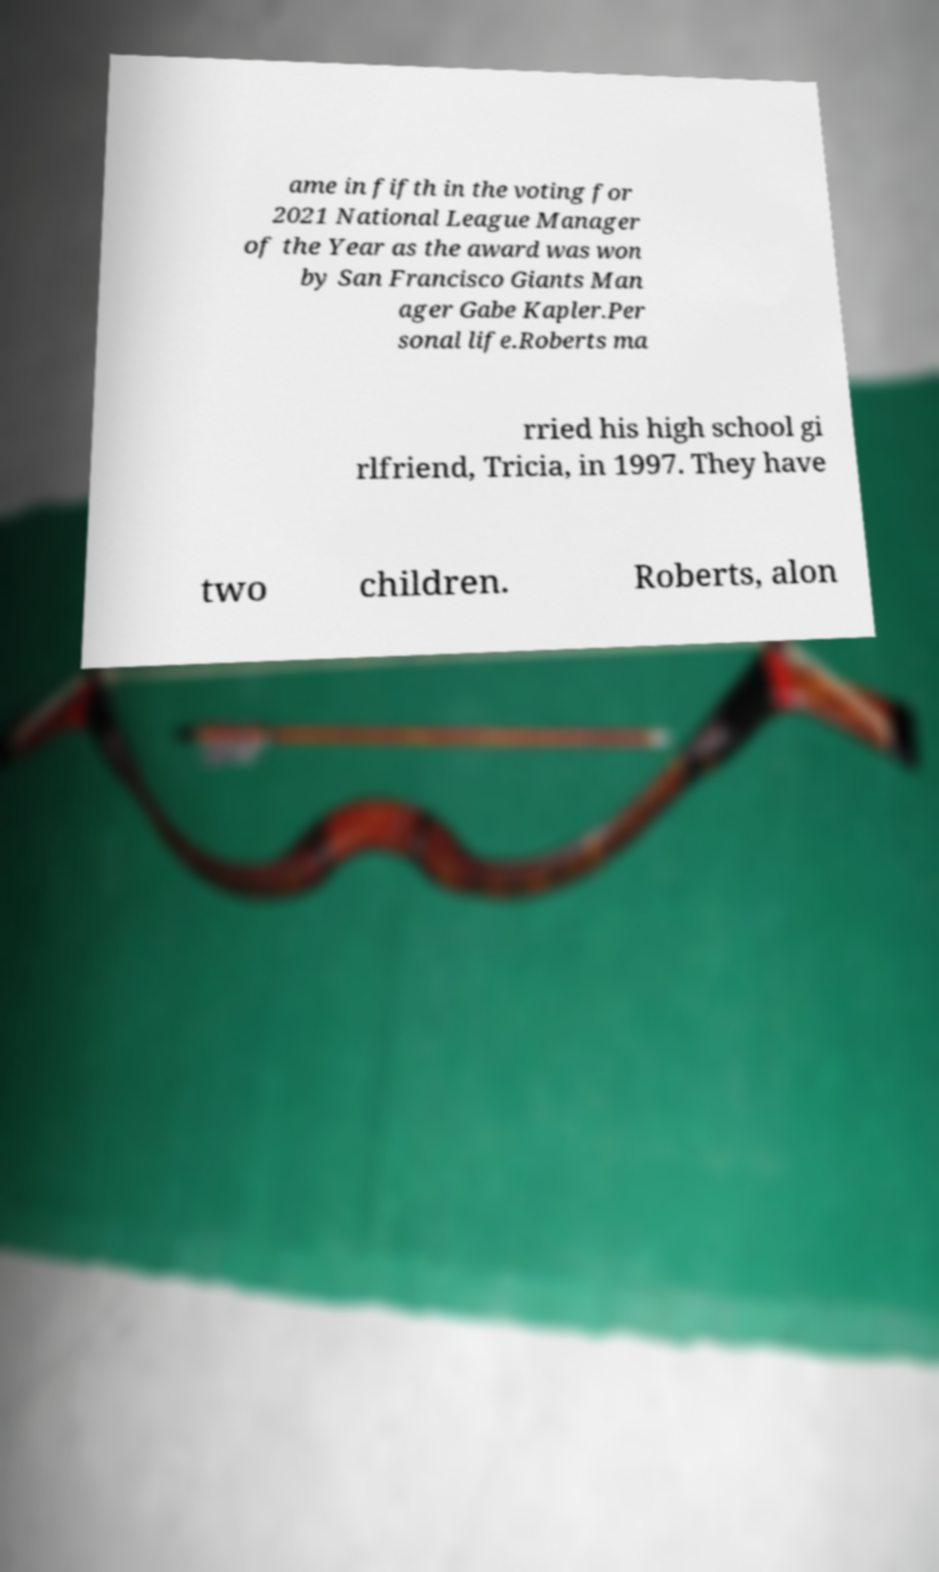Can you read and provide the text displayed in the image?This photo seems to have some interesting text. Can you extract and type it out for me? ame in fifth in the voting for 2021 National League Manager of the Year as the award was won by San Francisco Giants Man ager Gabe Kapler.Per sonal life.Roberts ma rried his high school gi rlfriend, Tricia, in 1997. They have two children. Roberts, alon 